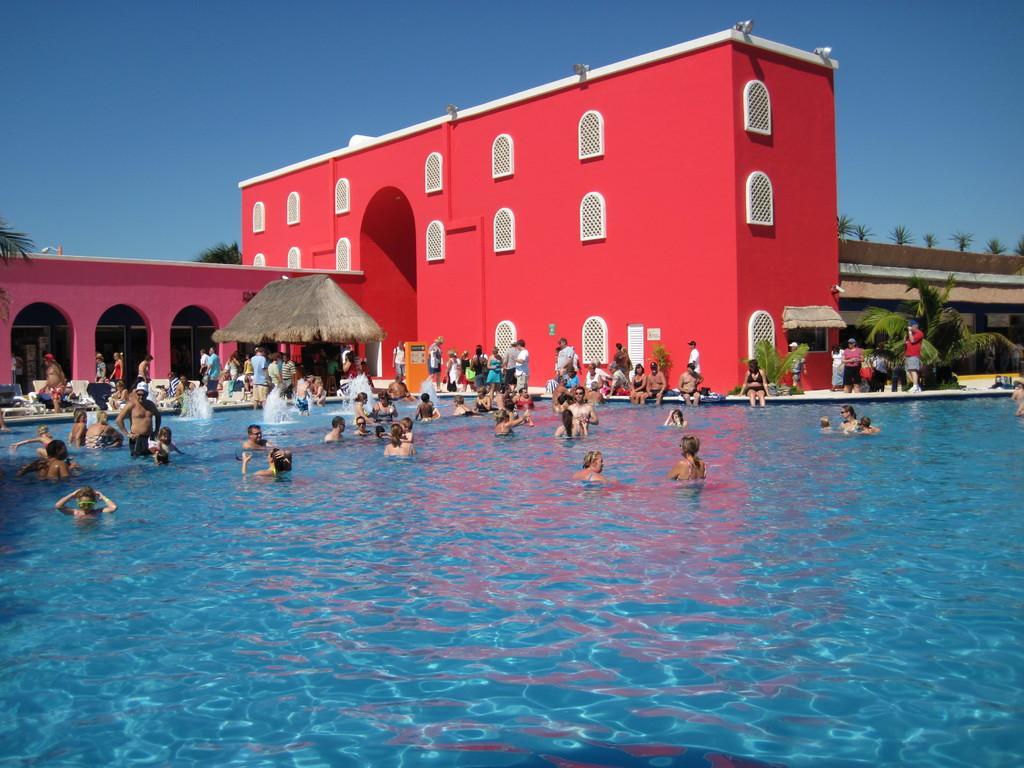Could you give a brief overview of what you see in this image? In the foreground of this image, there are people in the swimming pool. In the background, there are people sitting, standing and walking on the floor. We can also see the building, a hut, trees and the sky. 